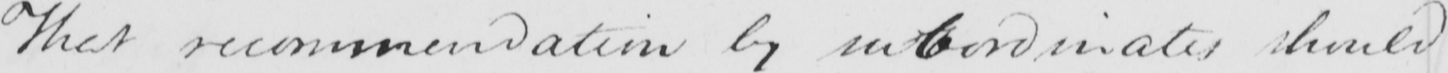Can you read and transcribe this handwriting? That recommendation by subordinates should 